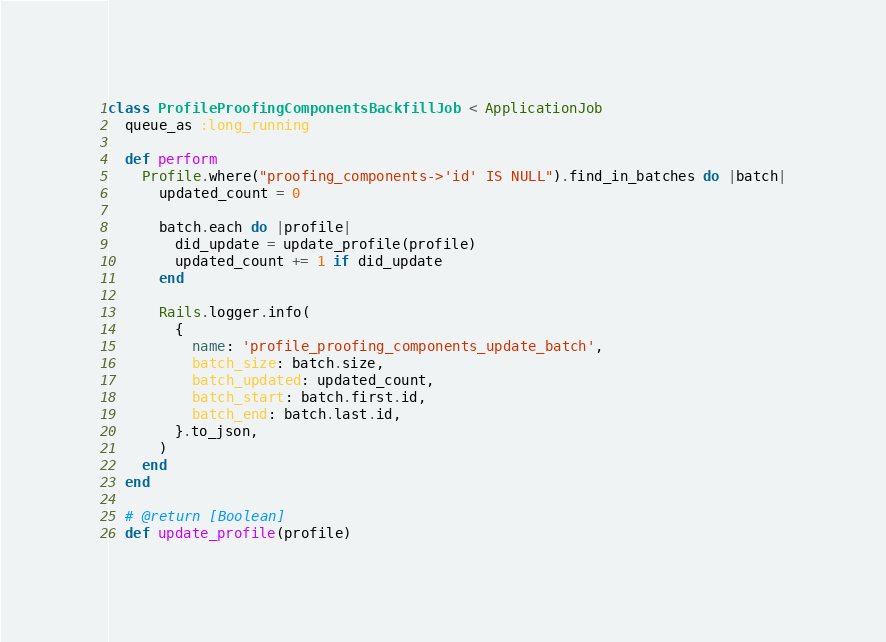Convert code to text. <code><loc_0><loc_0><loc_500><loc_500><_Ruby_>class ProfileProofingComponentsBackfillJob < ApplicationJob
  queue_as :long_running

  def perform
    Profile.where("proofing_components->'id' IS NULL").find_in_batches do |batch|
      updated_count = 0

      batch.each do |profile|
        did_update = update_profile(profile)
        updated_count += 1 if did_update
      end

      Rails.logger.info(
        {
          name: 'profile_proofing_components_update_batch',
          batch_size: batch.size,
          batch_updated: updated_count,
          batch_start: batch.first.id,
          batch_end: batch.last.id,
        }.to_json,
      )
    end
  end

  # @return [Boolean]
  def update_profile(profile)</code> 